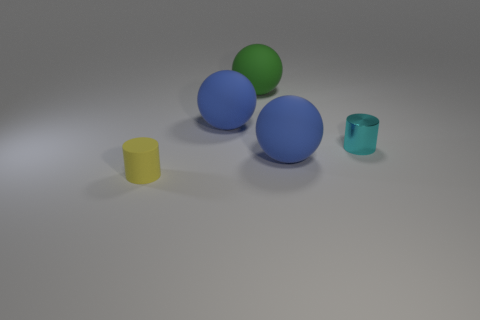What number of objects are either large green objects or tiny cyan metallic cylinders?
Ensure brevity in your answer.  2. There is a blue rubber ball that is in front of the tiny cyan metal cylinder; does it have the same size as the sphere on the left side of the large green thing?
Offer a very short reply. Yes. How many blocks are either tiny metal things or green rubber objects?
Offer a very short reply. 0. Is there a yellow rubber cylinder?
Offer a very short reply. Yes. Are there any other things that are the same shape as the cyan thing?
Your response must be concise. Yes. Does the metal thing have the same color as the small matte cylinder?
Your response must be concise. No. What number of things are either things behind the tiny rubber cylinder or cyan cylinders?
Give a very brief answer. 4. There is a big green object on the left side of the cylinder that is on the right side of the large green thing; how many cyan objects are to the left of it?
Ensure brevity in your answer.  0. Are there any other things that are the same size as the metal cylinder?
Your answer should be compact. Yes. What shape is the large blue object on the left side of the blue rubber thing that is in front of the blue rubber sphere behind the small metallic cylinder?
Your answer should be very brief. Sphere. 